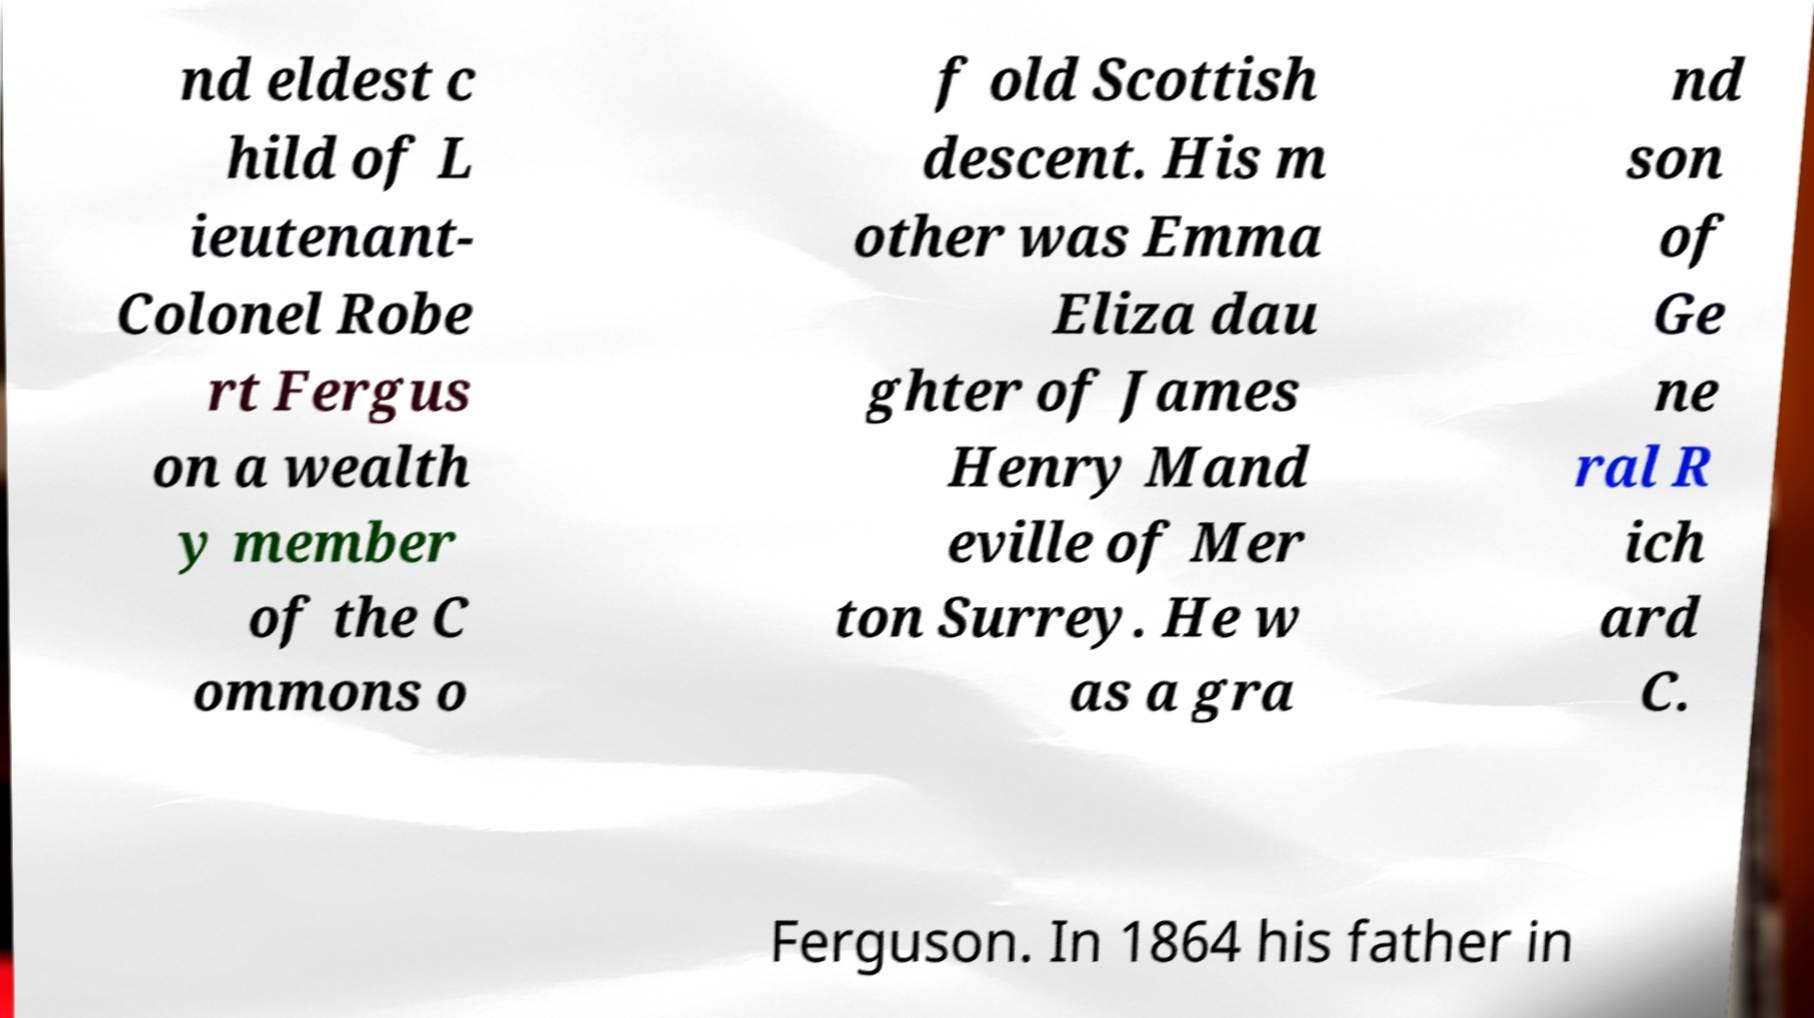Could you assist in decoding the text presented in this image and type it out clearly? nd eldest c hild of L ieutenant- Colonel Robe rt Fergus on a wealth y member of the C ommons o f old Scottish descent. His m other was Emma Eliza dau ghter of James Henry Mand eville of Mer ton Surrey. He w as a gra nd son of Ge ne ral R ich ard C. Ferguson. In 1864 his father in 